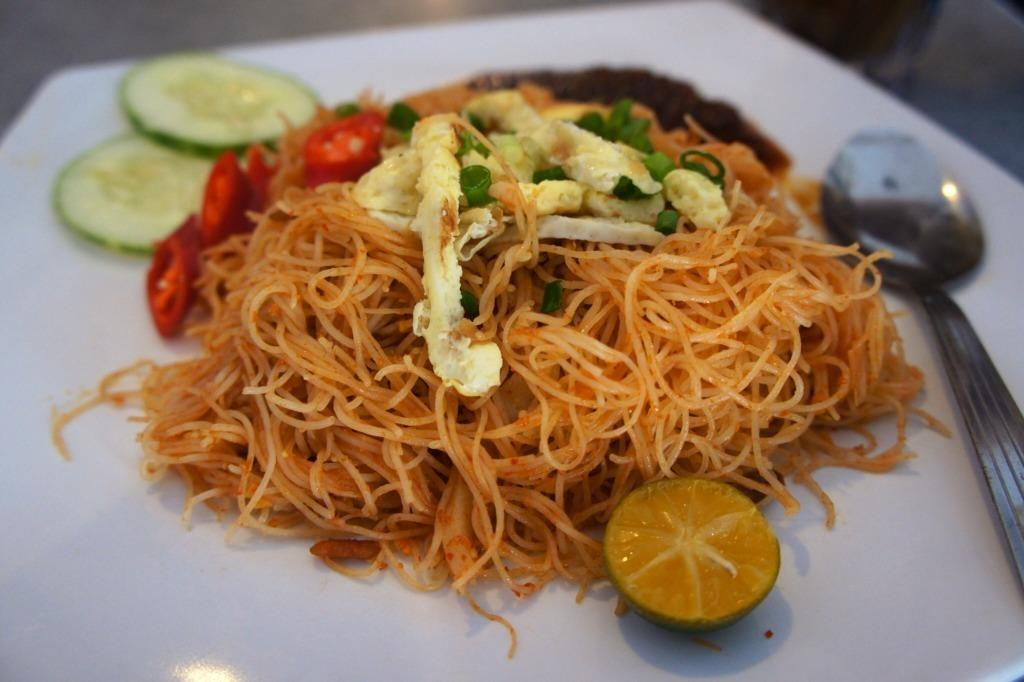What types of food items can be seen in the image? There are food items in the image, including a piece of lemon. What utensil is present in the image? There is a spoon in the image. On what is the food placed? The food items are placed on a white color tray. Can you describe the background of the image? The background of the image is blurred. What type of muscle is being exercised by the lemon in the image? There is no muscle present in the image, as it features food items and a spoon on a tray. 